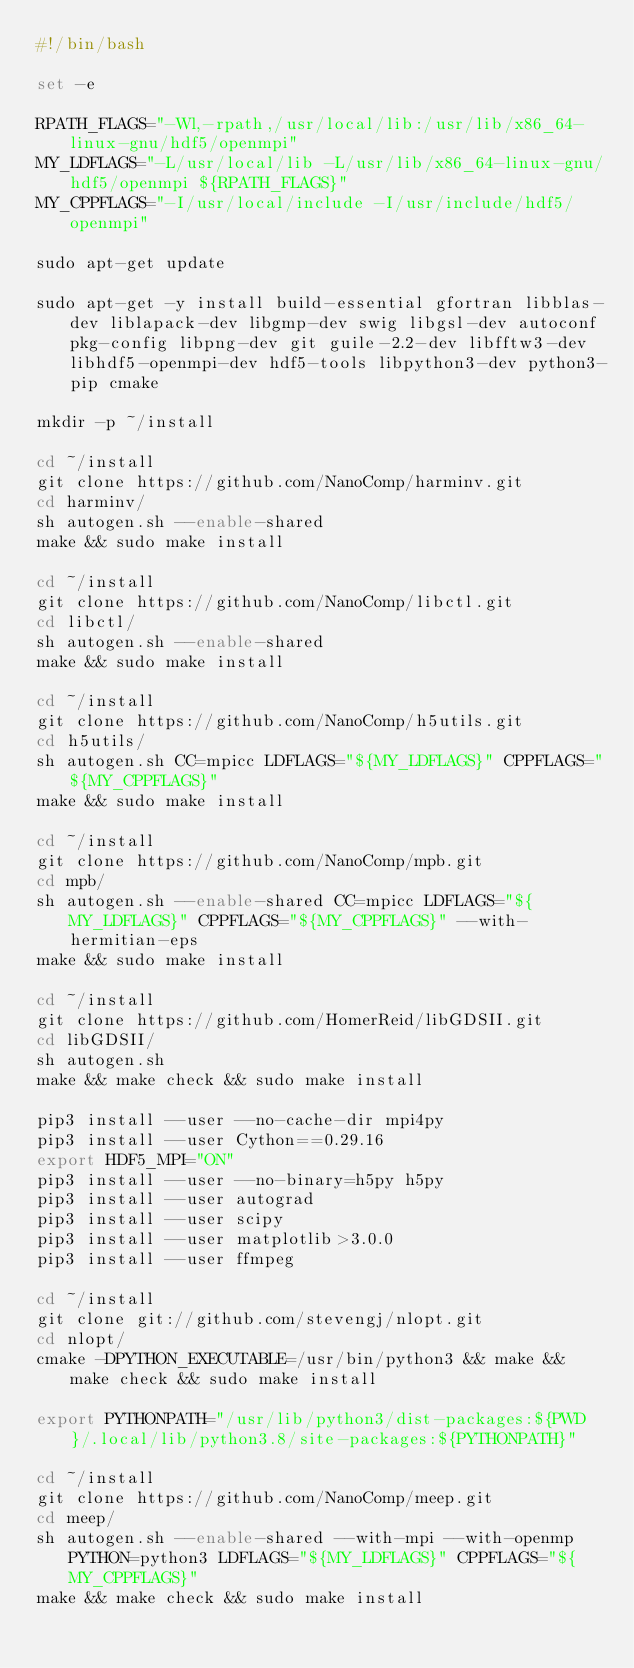Convert code to text. <code><loc_0><loc_0><loc_500><loc_500><_Bash_>#!/bin/bash

set -e

RPATH_FLAGS="-Wl,-rpath,/usr/local/lib:/usr/lib/x86_64-linux-gnu/hdf5/openmpi"
MY_LDFLAGS="-L/usr/local/lib -L/usr/lib/x86_64-linux-gnu/hdf5/openmpi ${RPATH_FLAGS}"
MY_CPPFLAGS="-I/usr/local/include -I/usr/include/hdf5/openmpi"

sudo apt-get update

sudo apt-get -y install build-essential gfortran libblas-dev liblapack-dev libgmp-dev swig libgsl-dev autoconf pkg-config libpng-dev git guile-2.2-dev libfftw3-dev libhdf5-openmpi-dev hdf5-tools libpython3-dev python3-pip cmake

mkdir -p ~/install

cd ~/install
git clone https://github.com/NanoComp/harminv.git
cd harminv/
sh autogen.sh --enable-shared
make && sudo make install

cd ~/install
git clone https://github.com/NanoComp/libctl.git
cd libctl/
sh autogen.sh --enable-shared
make && sudo make install

cd ~/install
git clone https://github.com/NanoComp/h5utils.git
cd h5utils/
sh autogen.sh CC=mpicc LDFLAGS="${MY_LDFLAGS}" CPPFLAGS="${MY_CPPFLAGS}"
make && sudo make install

cd ~/install
git clone https://github.com/NanoComp/mpb.git
cd mpb/
sh autogen.sh --enable-shared CC=mpicc LDFLAGS="${MY_LDFLAGS}" CPPFLAGS="${MY_CPPFLAGS}" --with-hermitian-eps
make && sudo make install

cd ~/install
git clone https://github.com/HomerReid/libGDSII.git
cd libGDSII/
sh autogen.sh
make && make check && sudo make install

pip3 install --user --no-cache-dir mpi4py
pip3 install --user Cython==0.29.16
export HDF5_MPI="ON"
pip3 install --user --no-binary=h5py h5py
pip3 install --user autograd
pip3 install --user scipy
pip3 install --user matplotlib>3.0.0
pip3 install --user ffmpeg

cd ~/install
git clone git://github.com/stevengj/nlopt.git
cd nlopt/
cmake -DPYTHON_EXECUTABLE=/usr/bin/python3 && make && make check && sudo make install

export PYTHONPATH="/usr/lib/python3/dist-packages:${PWD}/.local/lib/python3.8/site-packages:${PYTHONPATH}"

cd ~/install
git clone https://github.com/NanoComp/meep.git
cd meep/
sh autogen.sh --enable-shared --with-mpi --with-openmp PYTHON=python3 LDFLAGS="${MY_LDFLAGS}" CPPFLAGS="${MY_CPPFLAGS}"
make && make check && sudo make install
</code> 